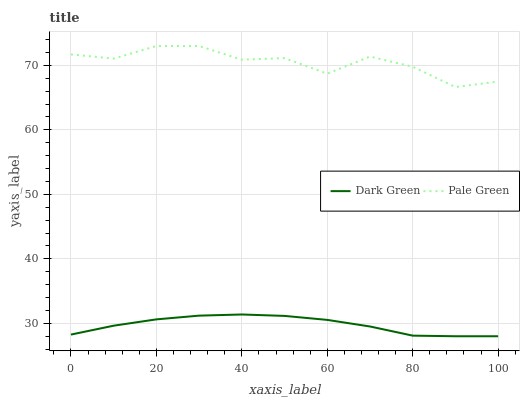Does Dark Green have the minimum area under the curve?
Answer yes or no. Yes. Does Pale Green have the maximum area under the curve?
Answer yes or no. Yes. Does Dark Green have the maximum area under the curve?
Answer yes or no. No. Is Dark Green the smoothest?
Answer yes or no. Yes. Is Pale Green the roughest?
Answer yes or no. Yes. Is Dark Green the roughest?
Answer yes or no. No. Does Dark Green have the lowest value?
Answer yes or no. Yes. Does Pale Green have the highest value?
Answer yes or no. Yes. Does Dark Green have the highest value?
Answer yes or no. No. Is Dark Green less than Pale Green?
Answer yes or no. Yes. Is Pale Green greater than Dark Green?
Answer yes or no. Yes. Does Dark Green intersect Pale Green?
Answer yes or no. No. 